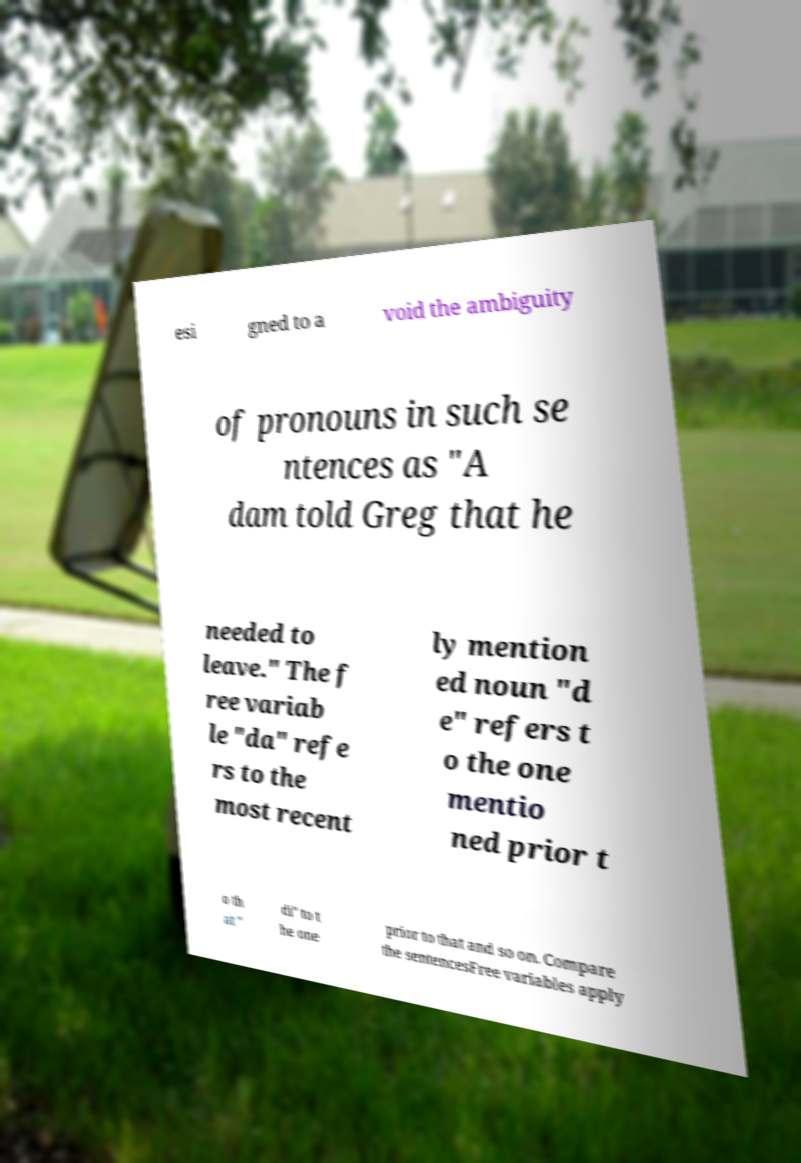Can you read and provide the text displayed in the image?This photo seems to have some interesting text. Can you extract and type it out for me? esi gned to a void the ambiguity of pronouns in such se ntences as "A dam told Greg that he needed to leave." The f ree variab le "da" refe rs to the most recent ly mention ed noun "d e" refers t o the one mentio ned prior t o th at " di" to t he one prior to that and so on. Compare the sentencesFree variables apply 